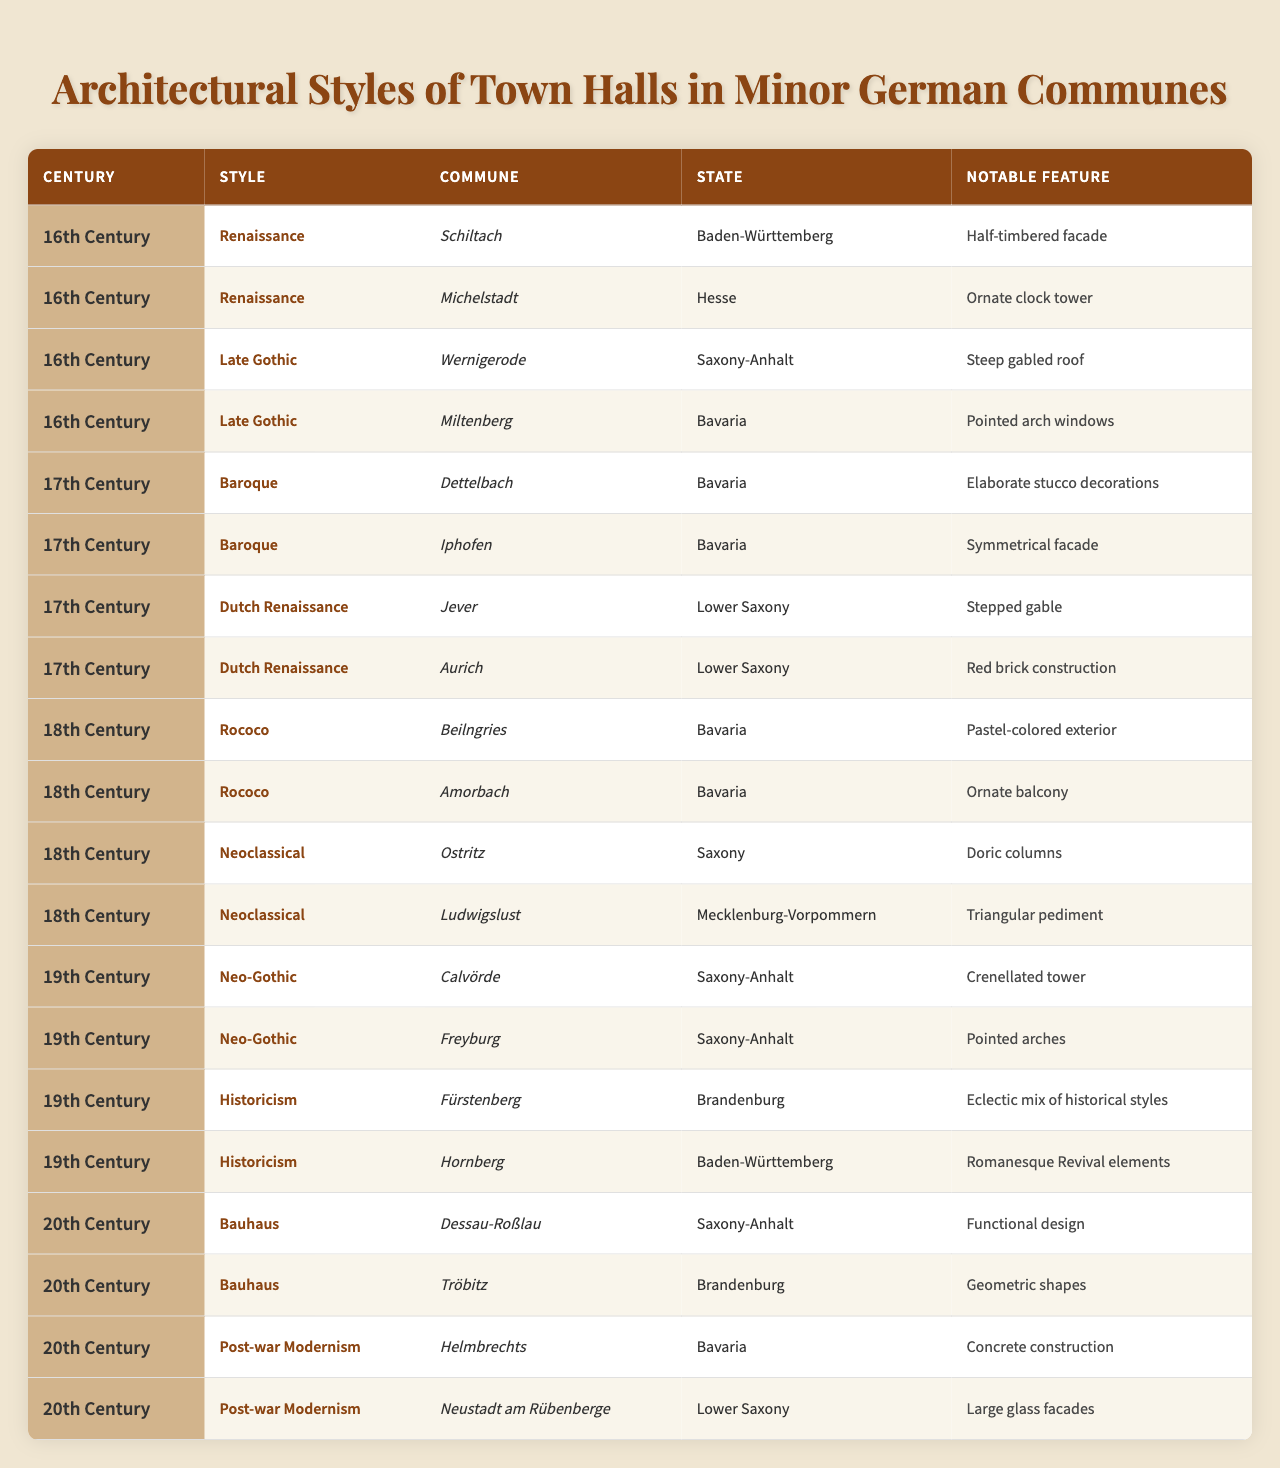Which architectural style is associated with Schiltach? Schiltach is listed under the 16th-century Renaissance style in the table.
Answer: Renaissance How many town halls built in the 18th century feature Neoclassical architecture? There are two town halls featuring Neoclassical architecture listed under the 18th century: Ostritz and Ludwigslust.
Answer: 2 What is a notable feature of the town hall in Miltenberg? The notable feature of the town hall in Miltenberg is pointed arch windows, as specified in the 16th-century section under Late Gothic style.
Answer: Pointed arch windows False or True: All the town halls in the 19th century are in Saxony-Anhalt. The statement is false. There are town halls from other states like Brandenburg and Baden-Württemberg in the 19th century.
Answer: False What is the notable feature of the town hall in Iphofen, and which architectural style does it belong to? The town hall in Iphofen features a symmetrical facade and belongs to the Baroque architectural style from the 17th century.
Answer: Symmetrical facade, Baroque In which century was the style of Rococo prominent, and how many communes showcase this style? Rococo was prominent in the 18th century, and there are two communes showcasing this style: Beilngries and Amorbach.
Answer: 18th century, 2 communes What states are represented by town halls built in the 20th century? The states represented by town halls built in the 20th century include Saxony-Anhalt, Brandenburg, and Bavaria.
Answer: Saxony-Anhalt, Brandenburg, Bavaria What is the difference in architectural styles between the town halls of Fürstenberg and Hornberg? Fürstenberg features an eclectic mix of historical styles, while Hornberg has Romanesque Revival elements. The difference lies in their stylistic approach.
Answer: Eclectic mix, Romanesque Revival How many different architectural styles are listed for the 17th century in the table? There are two different architectural styles listed for the 17th century: Baroque and Dutch Renaissance.
Answer: 2 Which commune from Bavaria features an elaborate stucco decoration? The commune from Bavaria featuring elaborate stucco decorations is Dettelbach, which is classified under the 17th-century Baroque style.
Answer: Dettelbach 